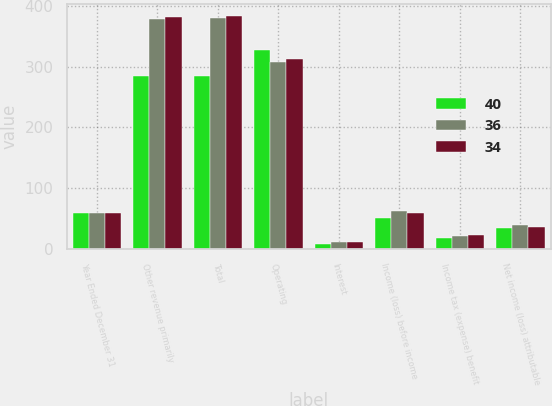<chart> <loc_0><loc_0><loc_500><loc_500><stacked_bar_chart><ecel><fcel>Year Ended December 31<fcel>Other revenue primarily<fcel>Total<fcel>Operating<fcel>Interest<fcel>Income (loss) before income<fcel>Income tax (expense) benefit<fcel>Net income (loss) attributable<nl><fcel>40<fcel>60<fcel>284<fcel>284<fcel>327<fcel>9<fcel>52<fcel>18<fcel>34<nl><fcel>36<fcel>60<fcel>379<fcel>380<fcel>307<fcel>11<fcel>62<fcel>22<fcel>40<nl><fcel>34<fcel>60<fcel>382<fcel>384<fcel>313<fcel>11<fcel>60<fcel>24<fcel>36<nl></chart> 